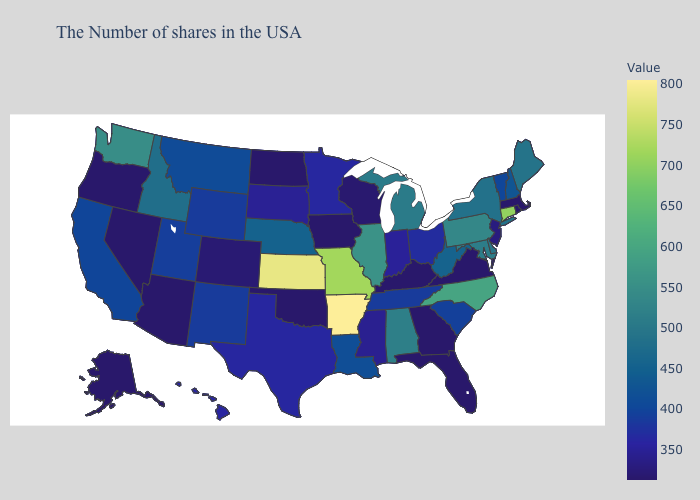Which states hav the highest value in the MidWest?
Write a very short answer. Kansas. Does Massachusetts have the lowest value in the Northeast?
Be succinct. Yes. Does Arkansas have the highest value in the South?
Short answer required. Yes. Which states have the highest value in the USA?
Write a very short answer. Arkansas. Does Arkansas have the highest value in the USA?
Short answer required. Yes. Does Georgia have the lowest value in the South?
Short answer required. Yes. Does Arkansas have the highest value in the South?
Concise answer only. Yes. Which states have the lowest value in the South?
Quick response, please. Virginia, Florida, Georgia, Kentucky, Oklahoma. 